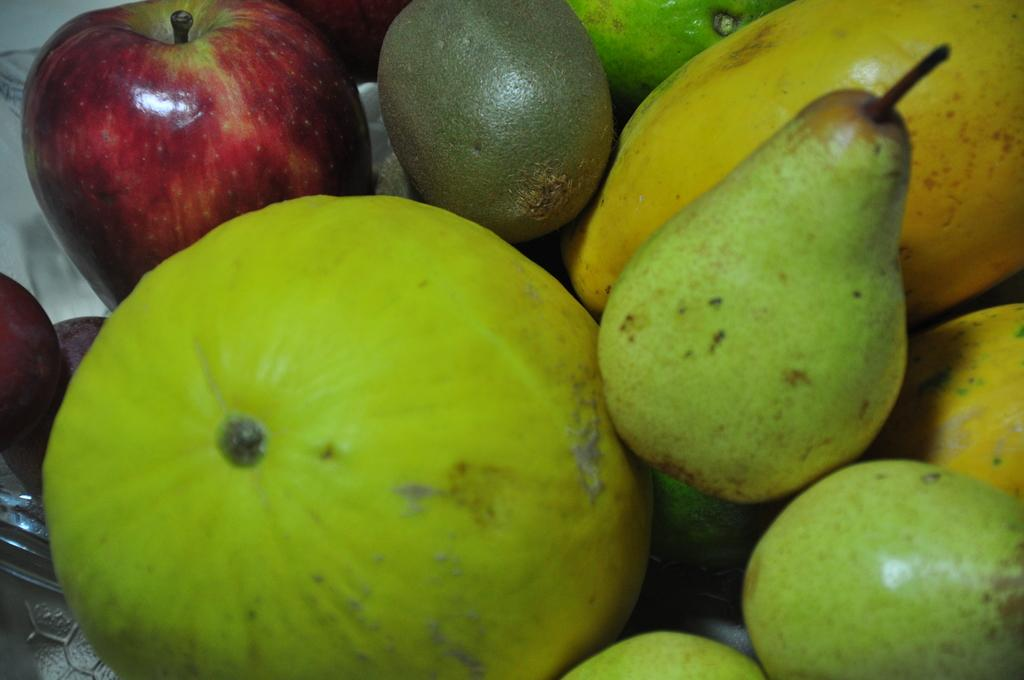What type of food is visible in the image? There is a group of fruits in the image. How are the fruits arranged in the image? The fruits are placed in a bowl. Where is the bowl located in the image? The bowl is kept on a surface. What type of watch is visible on the surface next to the bowl of fruits? There is no watch present in the image; only a group of fruits in a bowl on a surface is visible. 